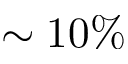Convert formula to latex. <formula><loc_0><loc_0><loc_500><loc_500>\sim 1 0 \%</formula> 